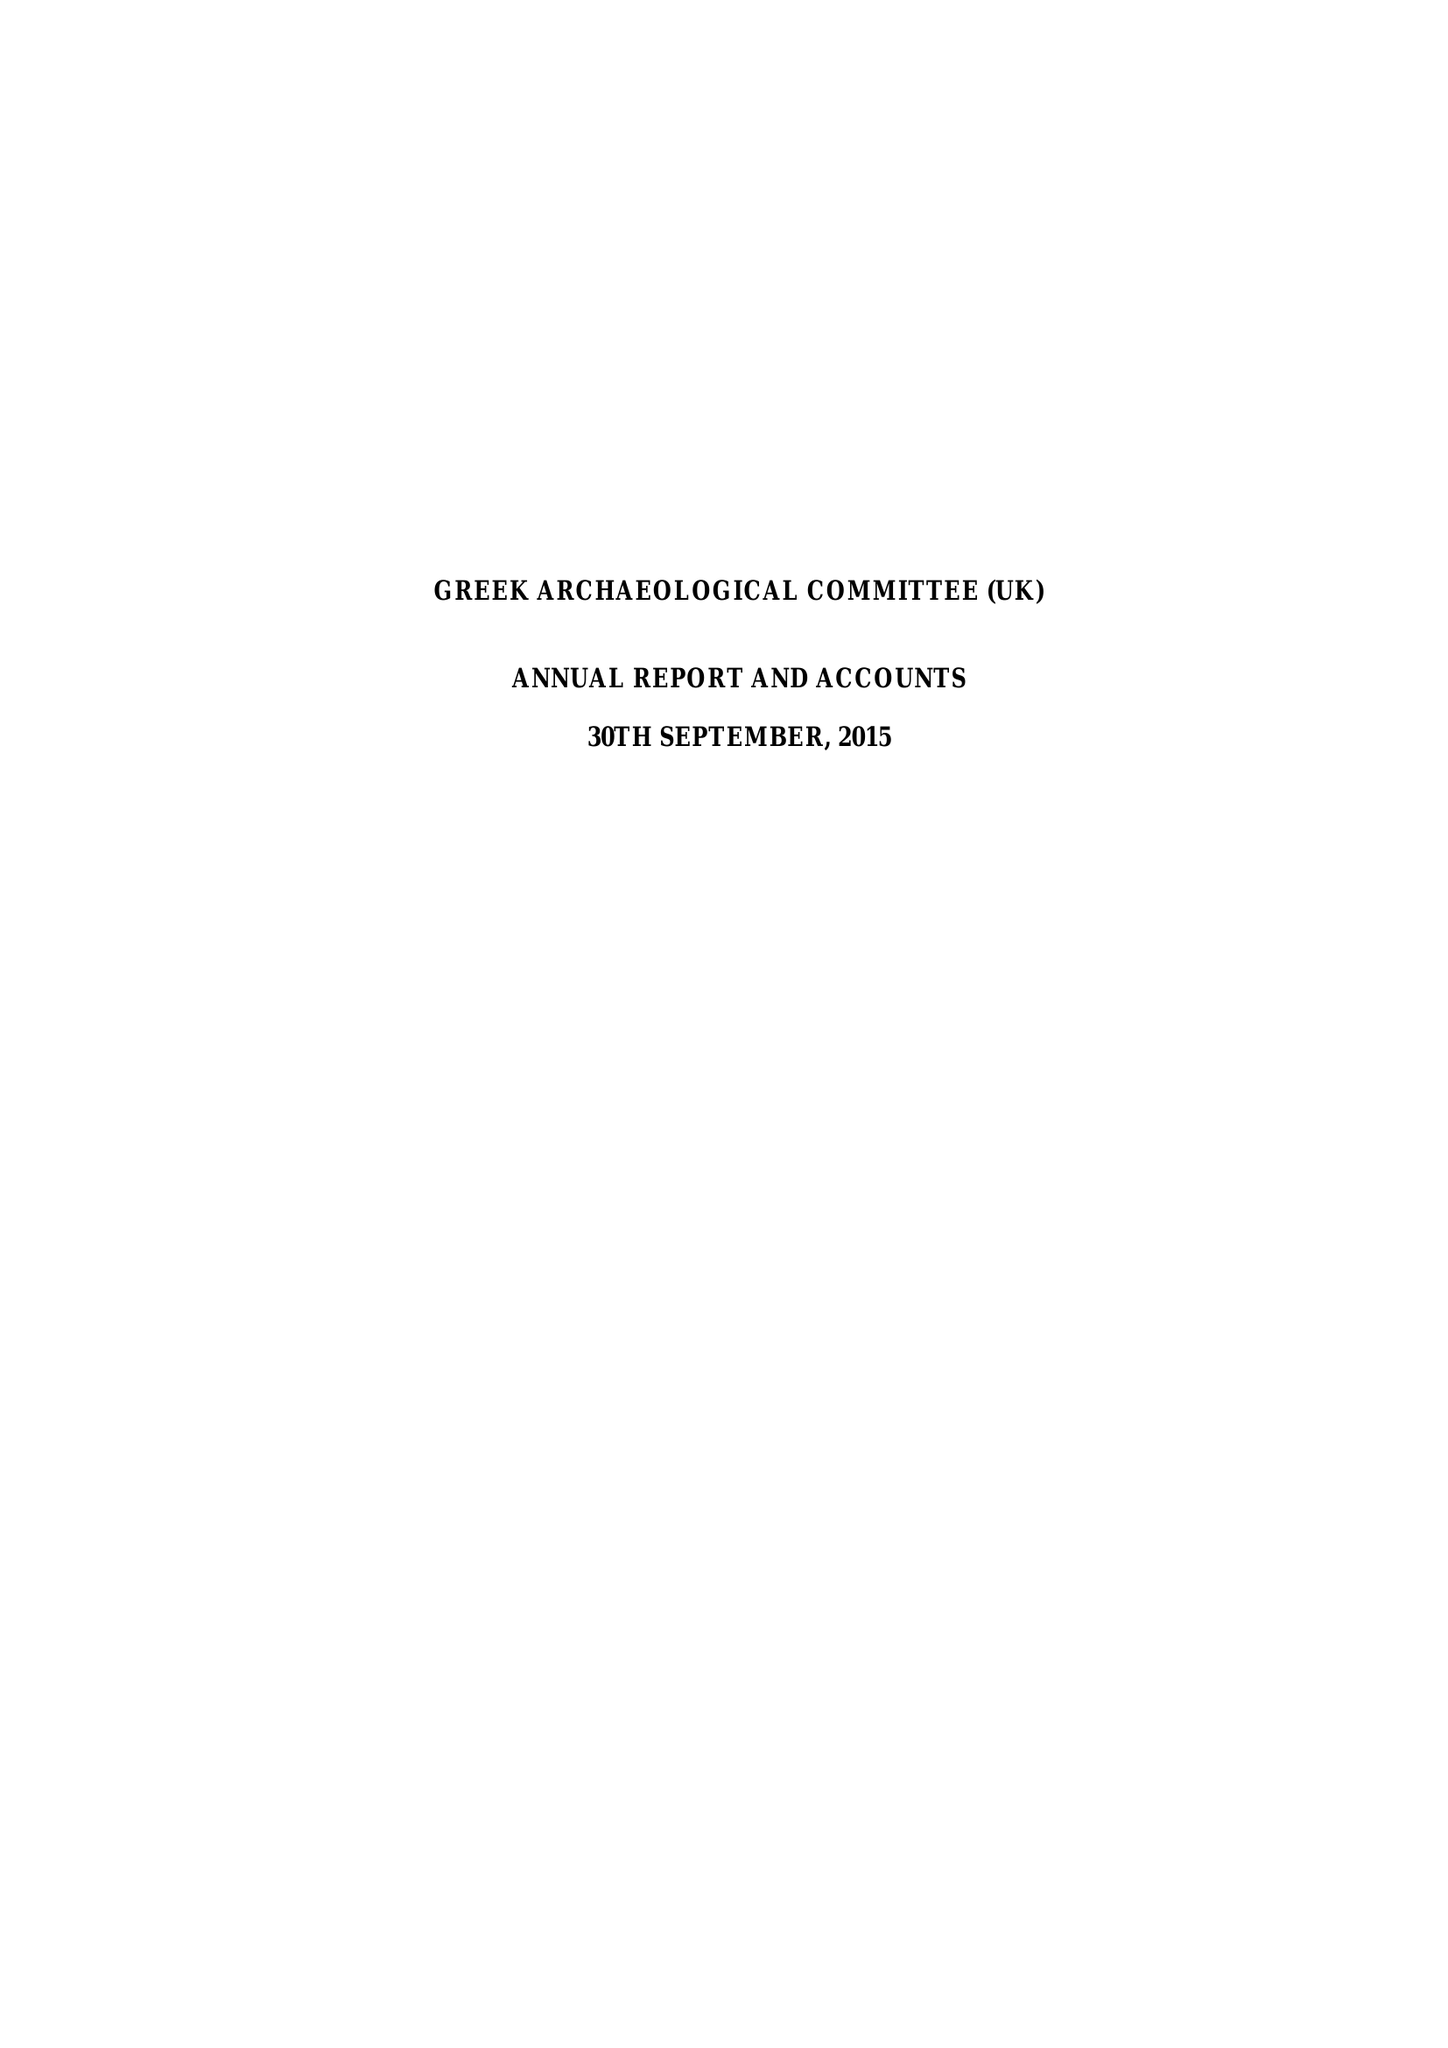What is the value for the report_date?
Answer the question using a single word or phrase. 2015-09-30 